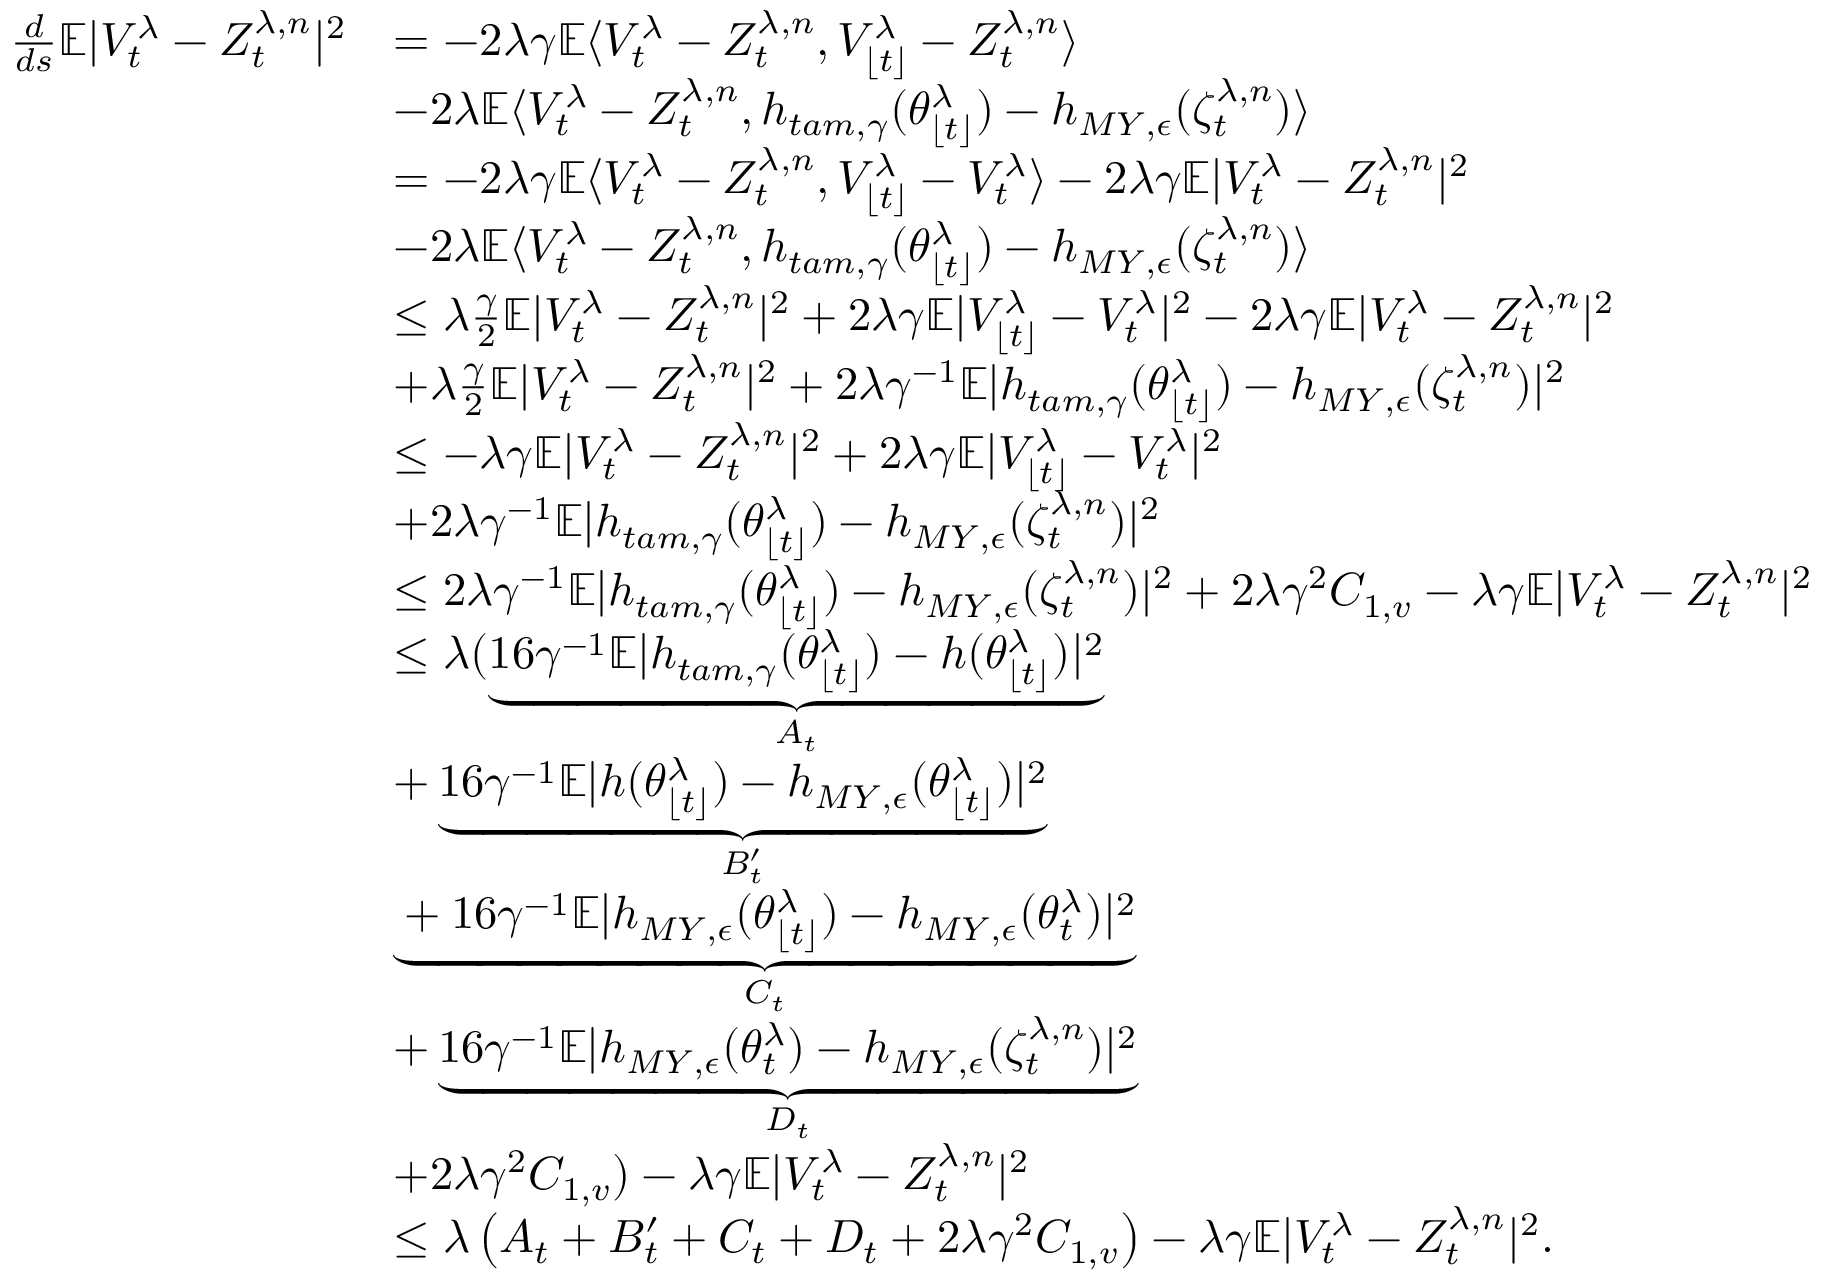<formula> <loc_0><loc_0><loc_500><loc_500>\begin{array} { r l } { \frac { d } { d s } \mathbb { E } | V _ { t } ^ { \lambda } - Z _ { t } ^ { \lambda , n } | ^ { 2 } } & { = - 2 \lambda \gamma \mathbb { E } \langle V _ { t } ^ { \lambda } - Z _ { t } ^ { \lambda , n } , V _ { \lfloor t \rfloor } ^ { \lambda } - Z _ { t } ^ { \lambda , n } \rangle } \\ & { - 2 \lambda \mathbb { E } \langle V _ { t } ^ { \lambda } - Z _ { t } ^ { \lambda , n } , h _ { t a m , \gamma } ( \theta _ { \lfloor t \rfloor } ^ { \lambda } ) - h _ { M Y , \epsilon } ( \zeta _ { t } ^ { \lambda , n } ) \rangle } \\ & { = - 2 \lambda \gamma \mathbb { E } \langle V _ { t } ^ { \lambda } - Z _ { t } ^ { \lambda , n } , V _ { \lfloor t \rfloor } ^ { \lambda } - V _ { t } ^ { \lambda } \rangle - 2 \lambda \gamma \mathbb { E } | V _ { t } ^ { \lambda } - Z _ { t } ^ { \lambda , n } | ^ { 2 } } \\ & { - 2 \lambda \mathbb { E } \langle V _ { t } ^ { \lambda } - Z _ { t } ^ { \lambda , n } , h _ { t a m , \gamma } ( \theta _ { \lfloor t \rfloor } ^ { \lambda } ) - h _ { M Y , \epsilon } ( \zeta _ { t } ^ { \lambda , n } ) \rangle } \\ & { \leq \lambda \frac { \gamma } { 2 } \mathbb { E } | V _ { t } ^ { \lambda } - Z _ { t } ^ { \lambda , n } | ^ { 2 } + 2 \lambda \gamma \mathbb { E } | V _ { \lfloor t \rfloor } ^ { \lambda } - V _ { t } ^ { \lambda } | ^ { 2 } - 2 \lambda \gamma \mathbb { E } | V _ { t } ^ { \lambda } - Z _ { t } ^ { \lambda , n } | ^ { 2 } } \\ & { + \lambda \frac { \gamma } { 2 } \mathbb { E } | V _ { t } ^ { \lambda } - Z _ { t } ^ { \lambda , n } | ^ { 2 } + 2 \lambda \gamma ^ { - 1 } \mathbb { E } | h _ { t a m , \gamma } ( \theta _ { \lfloor t \rfloor } ^ { \lambda } ) - h _ { M Y , \epsilon } ( \zeta _ { t } ^ { \lambda , n } ) | ^ { 2 } } \\ & { \leq - \lambda \gamma \mathbb { E } | V _ { t } ^ { \lambda } - Z _ { t } ^ { \lambda , n } | ^ { 2 } + 2 \lambda \gamma \mathbb { E } | V _ { \lfloor t \rfloor } ^ { \lambda } - V _ { t } ^ { \lambda } | ^ { 2 } } \\ & { + 2 \lambda \gamma ^ { - 1 } \mathbb { E } | h _ { t a m , \gamma } ( \theta _ { \lfloor t \rfloor } ^ { \lambda } ) - h _ { M Y , \epsilon } ( \zeta _ { t } ^ { \lambda , n } ) | ^ { 2 } } \\ & { \leq 2 \lambda \gamma ^ { - 1 } \mathbb { E } | h _ { t a m , \gamma } ( \theta _ { \lfloor t \rfloor } ^ { \lambda } ) - h _ { M Y , \epsilon } ( \zeta _ { t } ^ { \lambda , n } ) | ^ { 2 } + 2 \lambda \gamma ^ { 2 } C _ { 1 , v } - \lambda \gamma \mathbb { E } | V _ { t } ^ { \lambda } - Z _ { t } ^ { \lambda , n } | ^ { 2 } } \\ & { \leq \lambda ( \underbrace { 1 6 \gamma ^ { - 1 } \mathbb { E } | h _ { t a m , \gamma } ( \theta _ { \lfloor t \rfloor } ^ { \lambda } ) - h ( \theta _ { \lfloor t \rfloor } ^ { \lambda } ) | ^ { 2 } } _ { A _ { t } } } \\ & { + \underbrace { 1 6 \gamma ^ { - 1 } \mathbb { E } | h ( \theta _ { \lfloor t \rfloor } ^ { \lambda } ) - h _ { M Y , \epsilon } ( \theta _ { \lfloor t \rfloor } ^ { \lambda } ) | ^ { 2 } } _ { B _ { t } ^ { \prime } } } \\ & { \underbrace { + 1 6 \gamma ^ { - 1 } \mathbb { E } | h _ { M Y , \epsilon } ( \theta _ { \lfloor t \rfloor } ^ { \lambda } ) - h _ { M Y , \epsilon } ( \theta _ { t } ^ { \lambda } ) | ^ { 2 } } _ { C _ { t } } } \\ & { + \underbrace { 1 6 \gamma ^ { - 1 } \mathbb { E } | h _ { M Y , \epsilon } ( \theta _ { t } ^ { \lambda } ) - h _ { M Y , \epsilon } ( \zeta _ { t } ^ { \lambda , n } ) | ^ { 2 } } _ { D _ { t } } } \\ & { + 2 \lambda \gamma ^ { 2 } C _ { 1 , v } ) - \lambda \gamma \mathbb { E } | V _ { t } ^ { \lambda } - Z _ { t } ^ { \lambda , n } | ^ { 2 } } \\ & { \leq \lambda \left ( A _ { t } + B _ { t } ^ { \prime } + C _ { t } + D _ { t } + 2 \lambda \gamma ^ { 2 } C _ { 1 , v } \right ) - \lambda \gamma \mathbb { E } | V _ { t } ^ { \lambda } - Z _ { t } ^ { \lambda , n } | ^ { 2 } . } \end{array}</formula> 